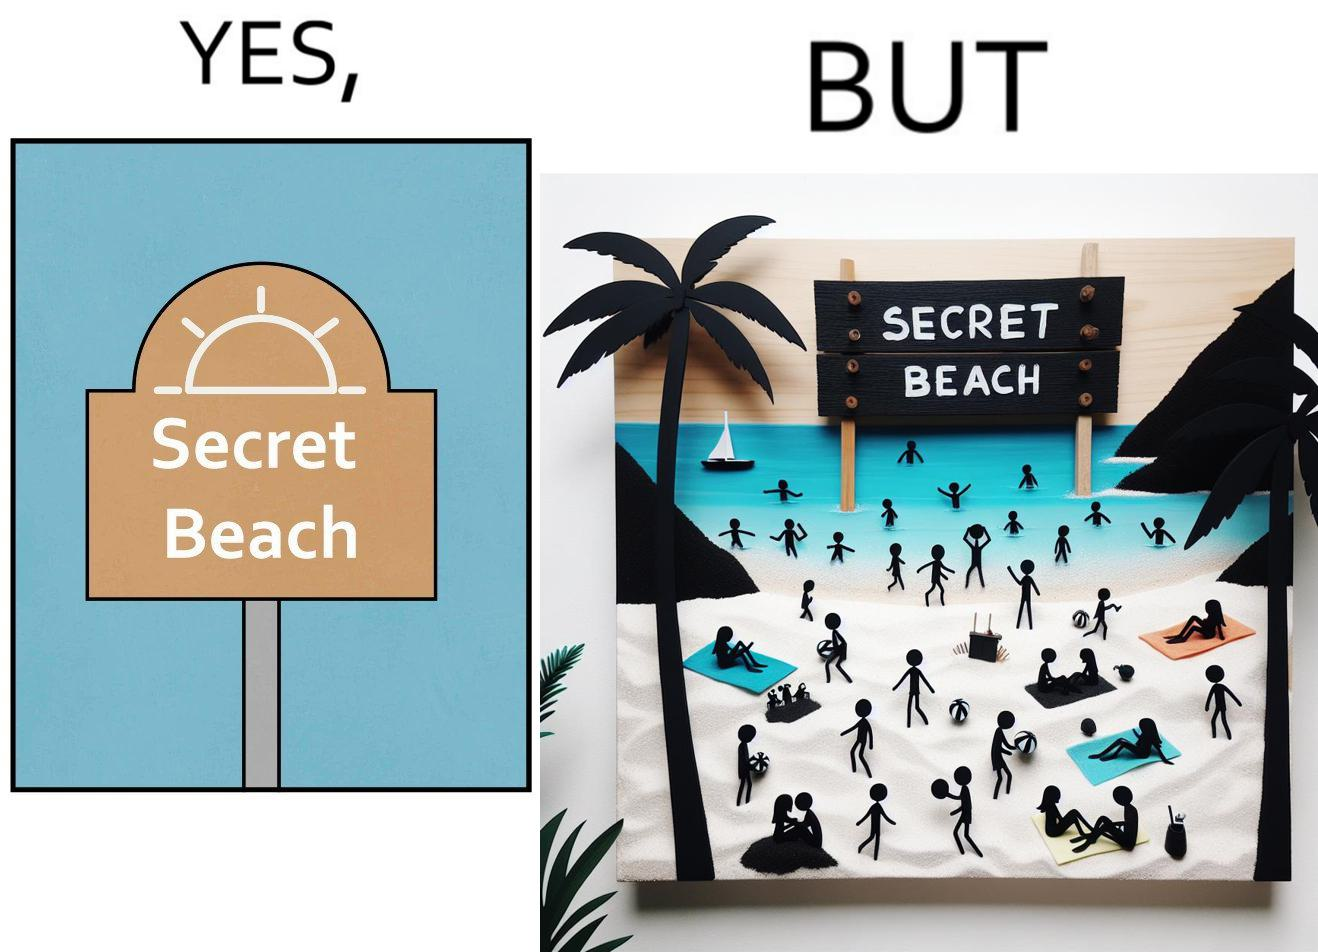Compare the left and right sides of this image. In the left part of the image: A board with "Secret Beach" written on it. In the right part of the image: People in a beach, having a board with "Secret Beach" written on it at its entrance. 